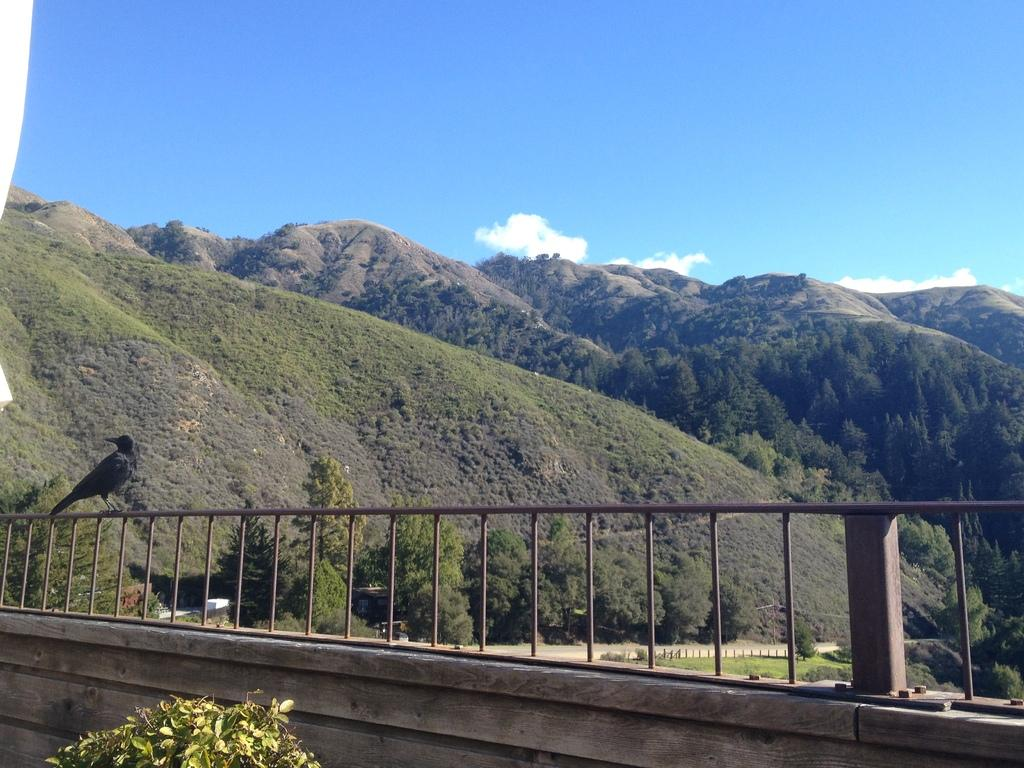What animal can be seen on the fence in the image? There is a bird on the fence in the image. What type of structures are visible in the image? There are poles and a wall visible in the image. What type of vegetation is present in the image? There is grass in the image. What can be seen in the background of the image? There are mountains, trees, and the sky visible in the background of the image. How does the bird crush the hall in the image? There is no bird crushing a hall in the image; the bird is perched on the fence. Is there any rain visible in the image? There is no rain visible in the image. 